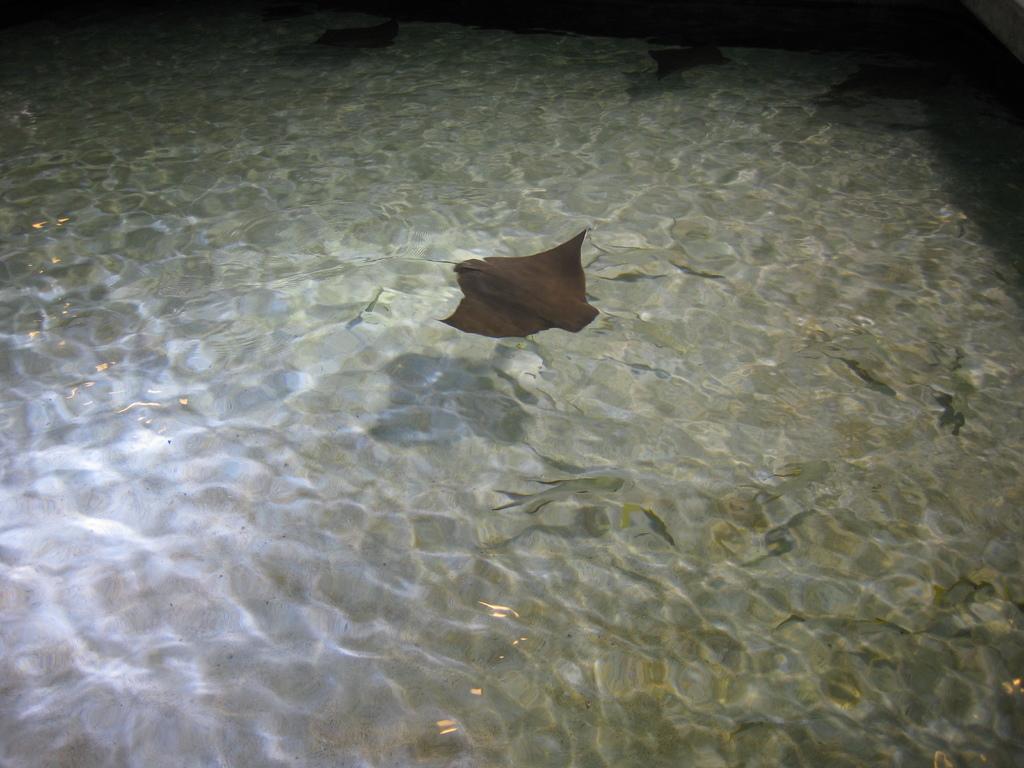Can you describe this image briefly? There is a ray fish and many other fishes in the water. 